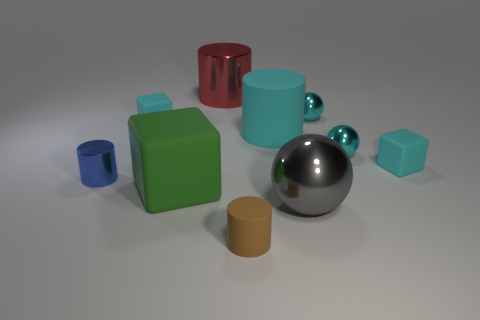Which object in the image seems to differ the most from the others in terms of its properties, and why? The red cylinder stands out because it has a reflective, shiny appearance suggesting a metallic material, unlike the matte finish of the other objects which seem to be made of plastic or similar materials. 